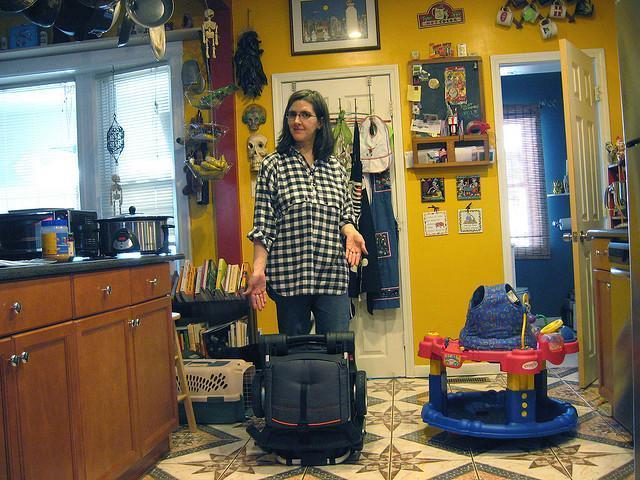How many books are in the photo?
Give a very brief answer. 1. 